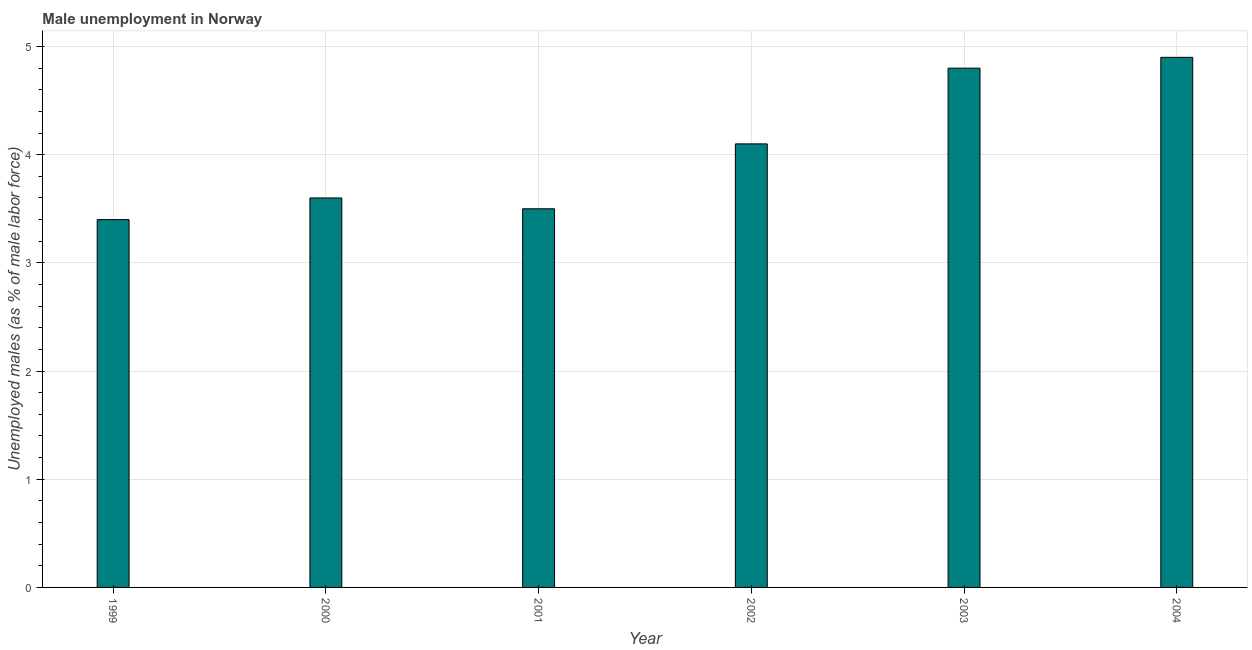What is the title of the graph?
Offer a very short reply. Male unemployment in Norway. What is the label or title of the Y-axis?
Keep it short and to the point. Unemployed males (as % of male labor force). What is the unemployed males population in 2001?
Your response must be concise. 3.5. Across all years, what is the maximum unemployed males population?
Keep it short and to the point. 4.9. Across all years, what is the minimum unemployed males population?
Offer a terse response. 3.4. In which year was the unemployed males population maximum?
Your answer should be very brief. 2004. In which year was the unemployed males population minimum?
Your response must be concise. 1999. What is the sum of the unemployed males population?
Offer a very short reply. 24.3. What is the average unemployed males population per year?
Provide a short and direct response. 4.05. What is the median unemployed males population?
Offer a very short reply. 3.85. In how many years, is the unemployed males population greater than 2 %?
Provide a succinct answer. 6. Do a majority of the years between 2003 and 2001 (inclusive) have unemployed males population greater than 3 %?
Make the answer very short. Yes. What is the ratio of the unemployed males population in 1999 to that in 2004?
Your answer should be compact. 0.69. Is the difference between the unemployed males population in 2000 and 2003 greater than the difference between any two years?
Offer a very short reply. No. What is the difference between the highest and the second highest unemployed males population?
Your answer should be compact. 0.1. Is the sum of the unemployed males population in 1999 and 2004 greater than the maximum unemployed males population across all years?
Your response must be concise. Yes. What is the difference between the highest and the lowest unemployed males population?
Your answer should be very brief. 1.5. In how many years, is the unemployed males population greater than the average unemployed males population taken over all years?
Offer a terse response. 3. How many bars are there?
Keep it short and to the point. 6. Are all the bars in the graph horizontal?
Provide a short and direct response. No. What is the Unemployed males (as % of male labor force) of 1999?
Offer a terse response. 3.4. What is the Unemployed males (as % of male labor force) in 2000?
Ensure brevity in your answer.  3.6. What is the Unemployed males (as % of male labor force) in 2001?
Ensure brevity in your answer.  3.5. What is the Unemployed males (as % of male labor force) in 2002?
Offer a very short reply. 4.1. What is the Unemployed males (as % of male labor force) of 2003?
Provide a succinct answer. 4.8. What is the Unemployed males (as % of male labor force) of 2004?
Give a very brief answer. 4.9. What is the difference between the Unemployed males (as % of male labor force) in 1999 and 2000?
Give a very brief answer. -0.2. What is the difference between the Unemployed males (as % of male labor force) in 1999 and 2002?
Ensure brevity in your answer.  -0.7. What is the difference between the Unemployed males (as % of male labor force) in 1999 and 2003?
Provide a succinct answer. -1.4. What is the difference between the Unemployed males (as % of male labor force) in 1999 and 2004?
Give a very brief answer. -1.5. What is the difference between the Unemployed males (as % of male labor force) in 2000 and 2001?
Keep it short and to the point. 0.1. What is the difference between the Unemployed males (as % of male labor force) in 2000 and 2002?
Give a very brief answer. -0.5. What is the difference between the Unemployed males (as % of male labor force) in 2000 and 2003?
Provide a short and direct response. -1.2. What is the difference between the Unemployed males (as % of male labor force) in 2001 and 2004?
Provide a succinct answer. -1.4. What is the difference between the Unemployed males (as % of male labor force) in 2002 and 2003?
Offer a very short reply. -0.7. What is the difference between the Unemployed males (as % of male labor force) in 2002 and 2004?
Offer a very short reply. -0.8. What is the ratio of the Unemployed males (as % of male labor force) in 1999 to that in 2000?
Provide a short and direct response. 0.94. What is the ratio of the Unemployed males (as % of male labor force) in 1999 to that in 2001?
Ensure brevity in your answer.  0.97. What is the ratio of the Unemployed males (as % of male labor force) in 1999 to that in 2002?
Your answer should be compact. 0.83. What is the ratio of the Unemployed males (as % of male labor force) in 1999 to that in 2003?
Keep it short and to the point. 0.71. What is the ratio of the Unemployed males (as % of male labor force) in 1999 to that in 2004?
Your response must be concise. 0.69. What is the ratio of the Unemployed males (as % of male labor force) in 2000 to that in 2001?
Ensure brevity in your answer.  1.03. What is the ratio of the Unemployed males (as % of male labor force) in 2000 to that in 2002?
Keep it short and to the point. 0.88. What is the ratio of the Unemployed males (as % of male labor force) in 2000 to that in 2004?
Make the answer very short. 0.73. What is the ratio of the Unemployed males (as % of male labor force) in 2001 to that in 2002?
Your answer should be very brief. 0.85. What is the ratio of the Unemployed males (as % of male labor force) in 2001 to that in 2003?
Offer a terse response. 0.73. What is the ratio of the Unemployed males (as % of male labor force) in 2001 to that in 2004?
Provide a short and direct response. 0.71. What is the ratio of the Unemployed males (as % of male labor force) in 2002 to that in 2003?
Ensure brevity in your answer.  0.85. What is the ratio of the Unemployed males (as % of male labor force) in 2002 to that in 2004?
Offer a terse response. 0.84. What is the ratio of the Unemployed males (as % of male labor force) in 2003 to that in 2004?
Your answer should be very brief. 0.98. 